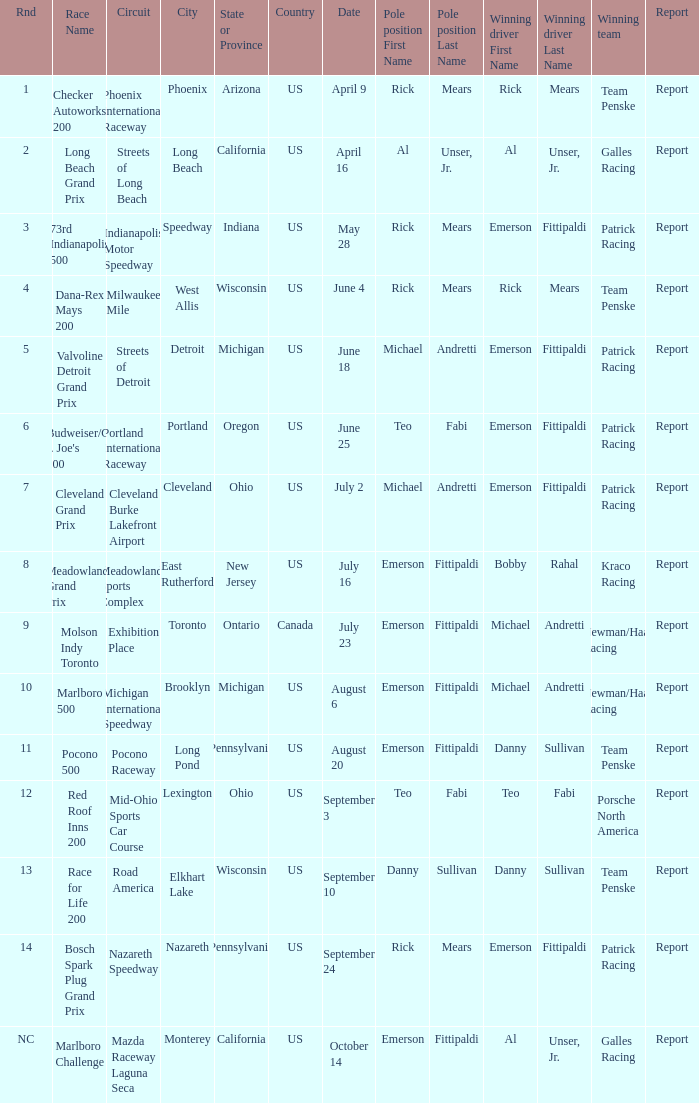How many reports were the for the cleveland burke lakefront airport circut? 1.0. 